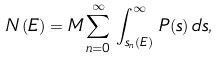<formula> <loc_0><loc_0><loc_500><loc_500>N \left ( E \right ) = M \sum _ { n = 0 } ^ { \infty } \, \int _ { s _ { n } \left ( E \right ) } ^ { \infty } \, P ( s ) \, d s ,</formula> 